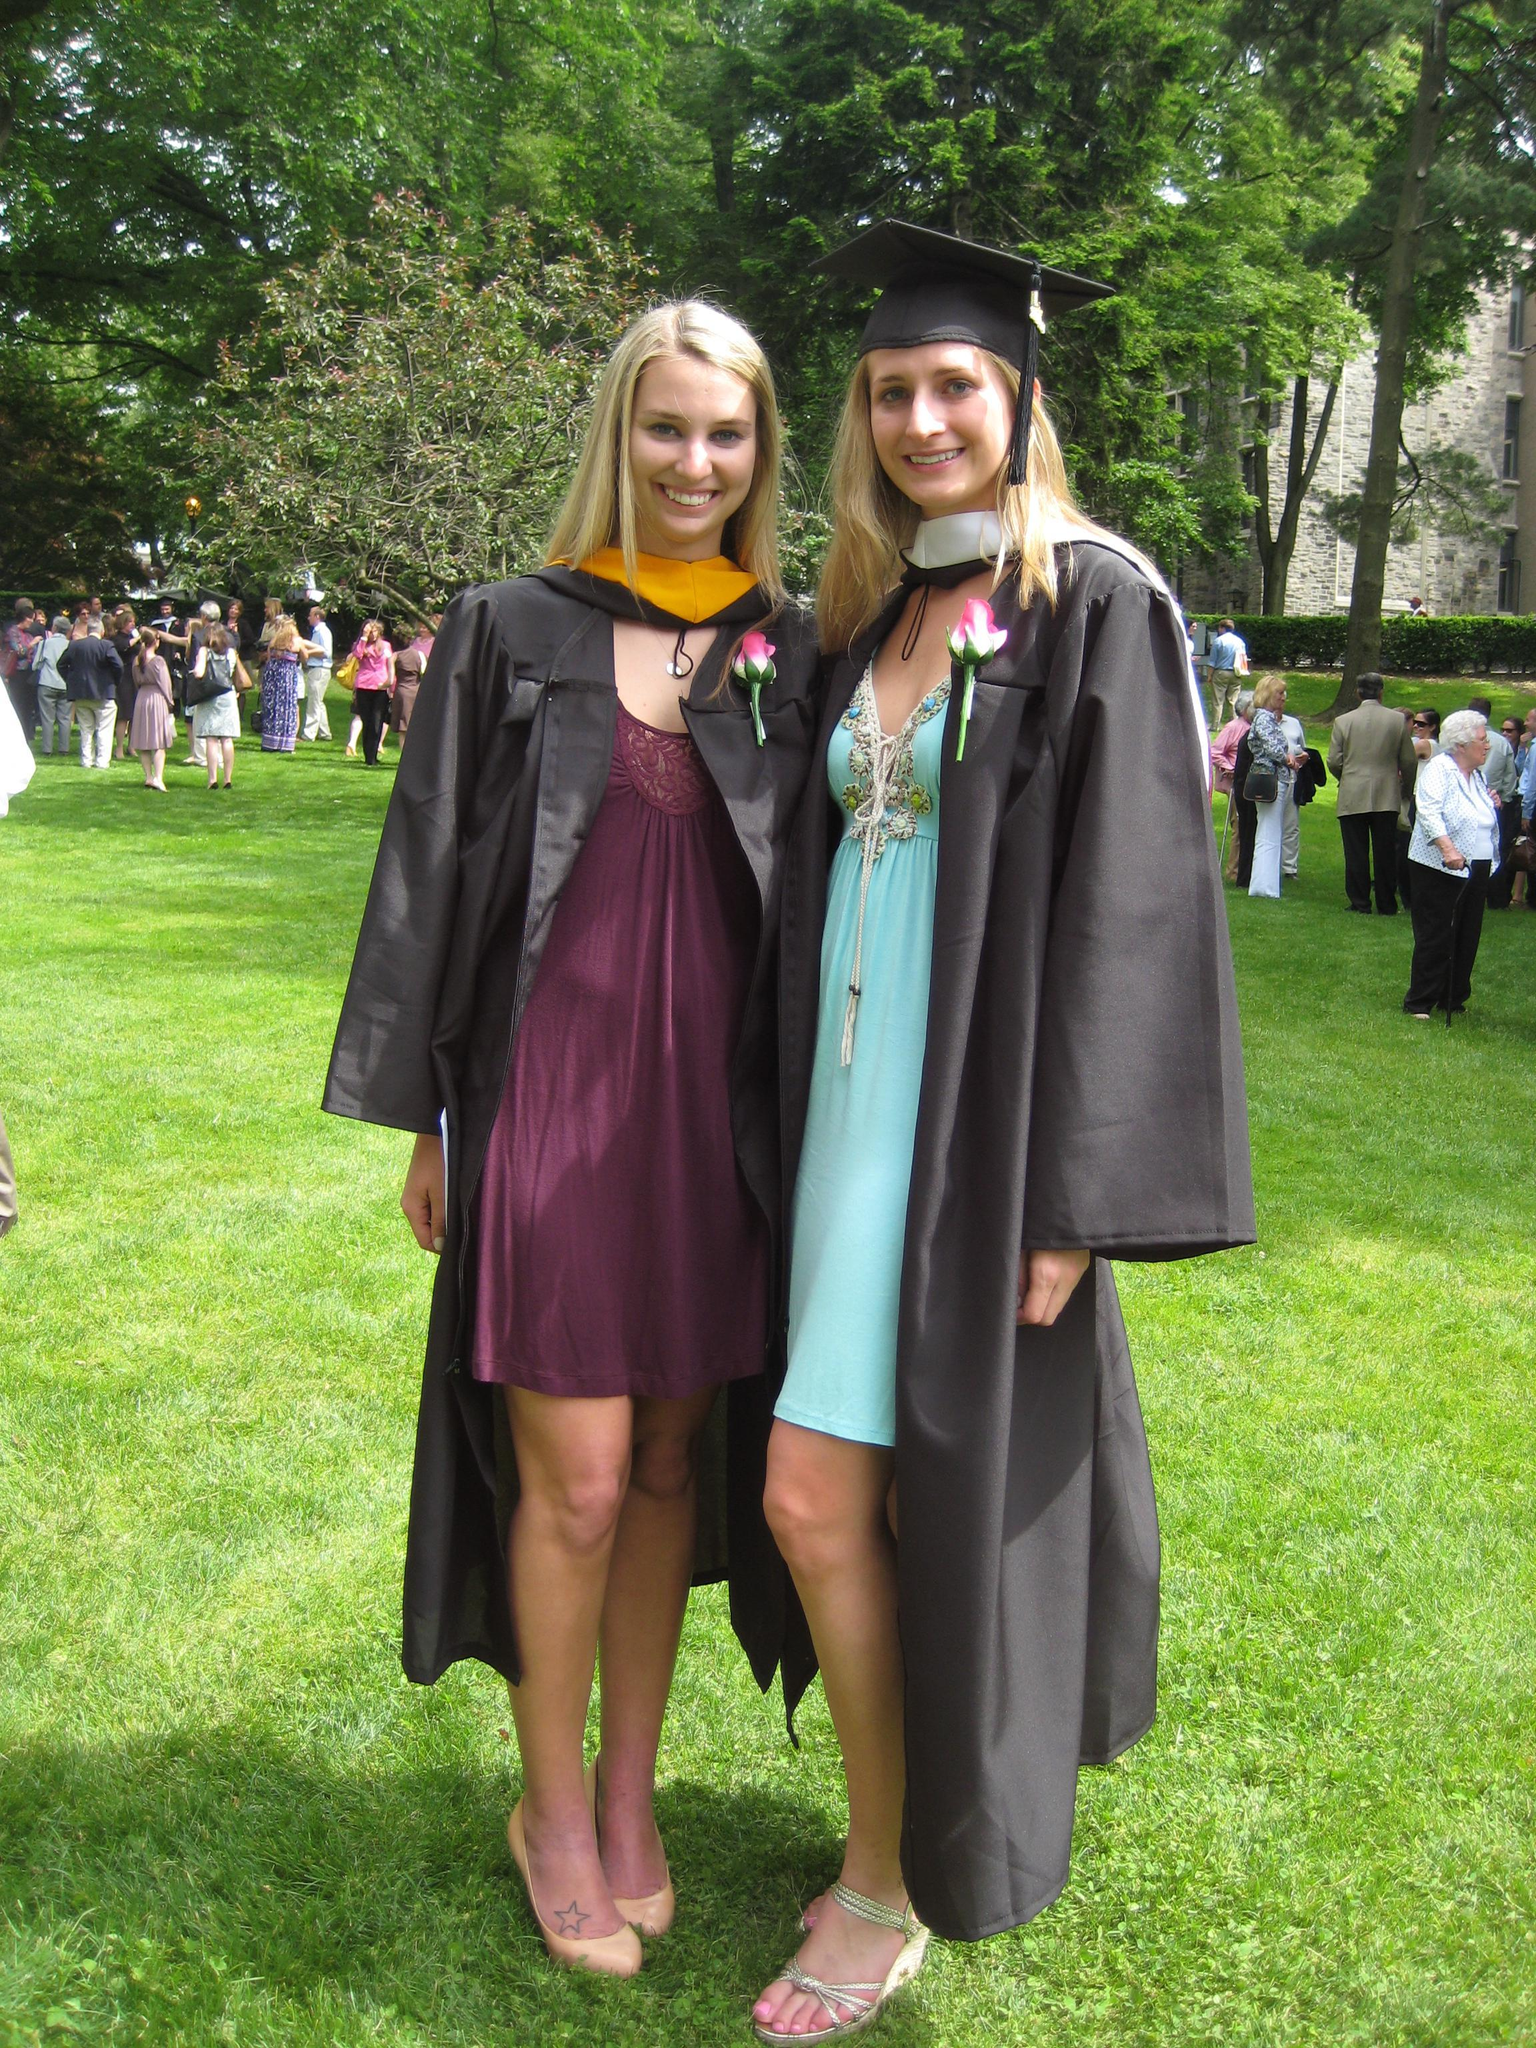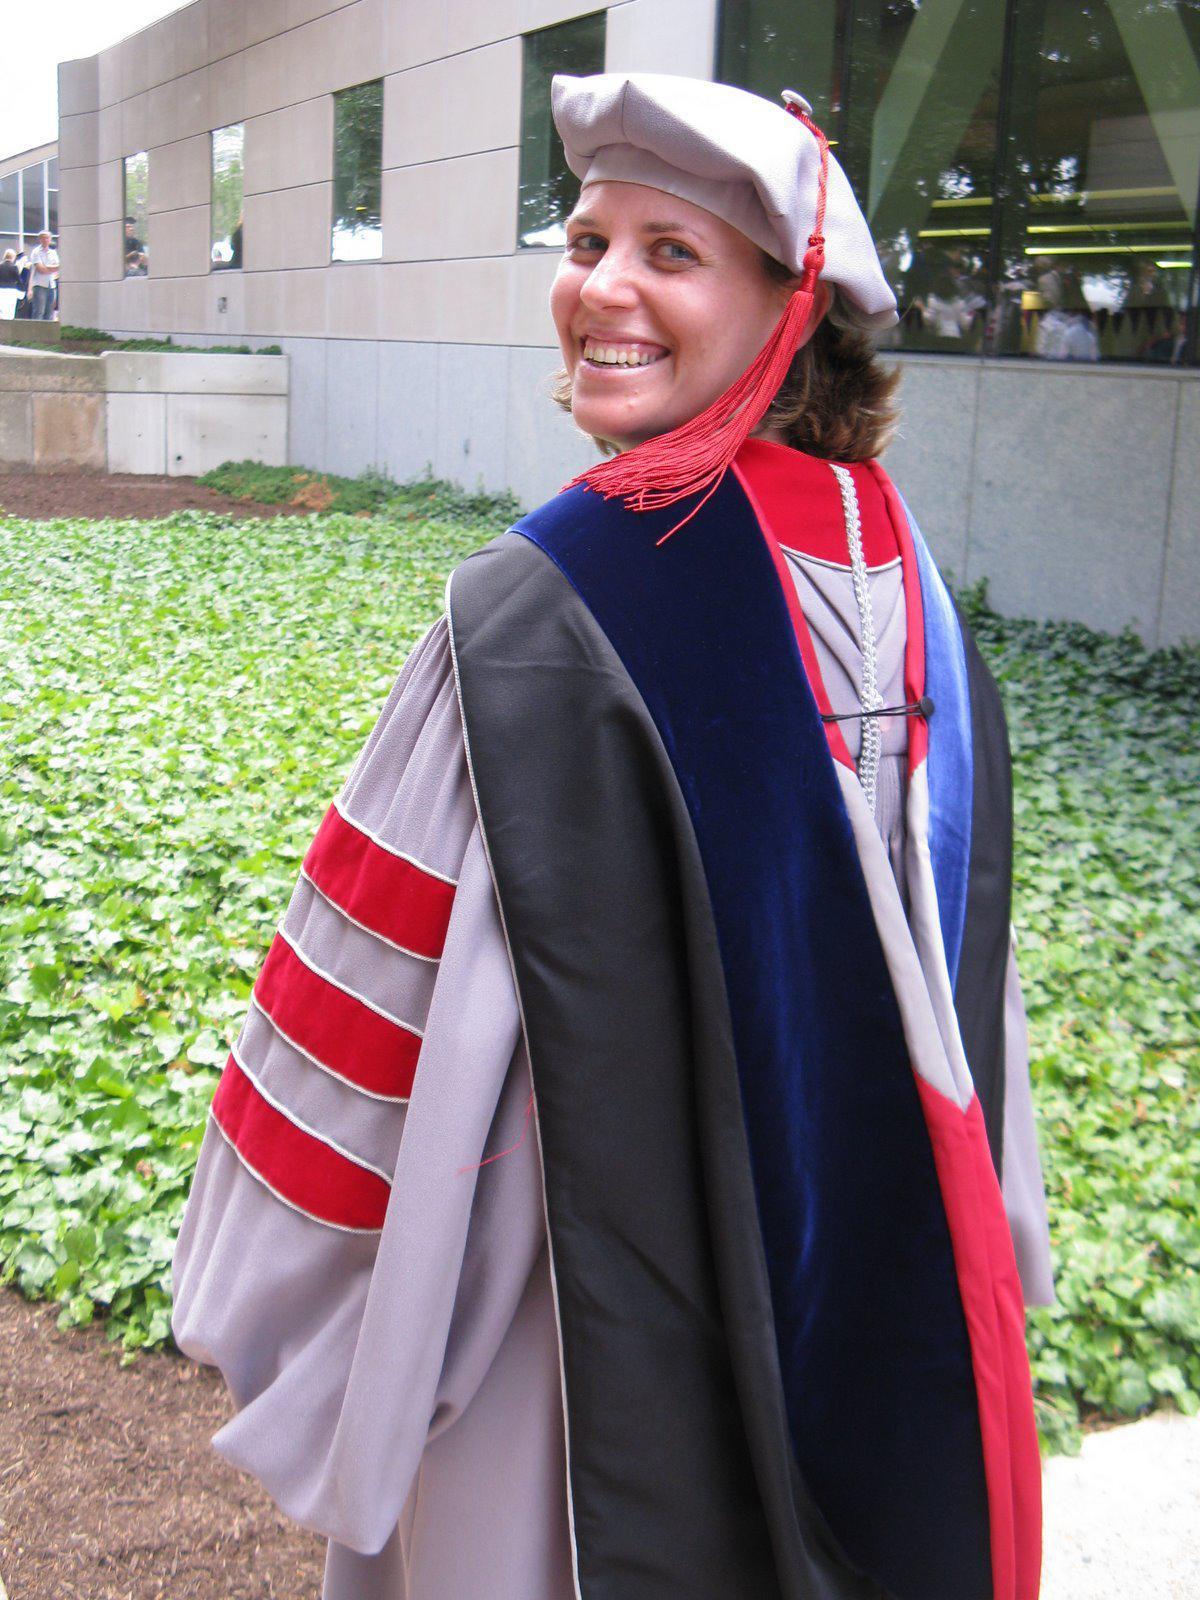The first image is the image on the left, the second image is the image on the right. Examine the images to the left and right. Is the description "There is a lone woman centered in one image." accurate? Answer yes or no. Yes. The first image is the image on the left, the second image is the image on the right. Examine the images to the left and right. Is the description "There are at most 3 graduation gowns in the image pair" accurate? Answer yes or no. Yes. 